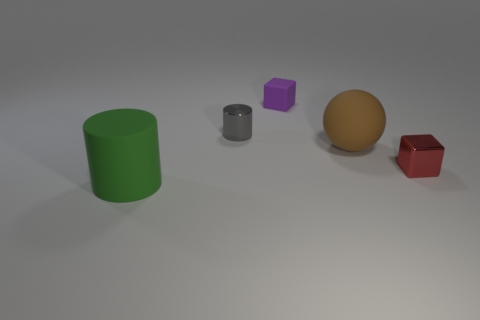Add 3 spheres. How many objects exist? 8 Subtract all cylinders. How many objects are left? 3 Add 3 tiny matte cubes. How many tiny matte cubes exist? 4 Subtract 1 brown balls. How many objects are left? 4 Subtract all small yellow shiny balls. Subtract all purple rubber things. How many objects are left? 4 Add 3 tiny things. How many tiny things are left? 6 